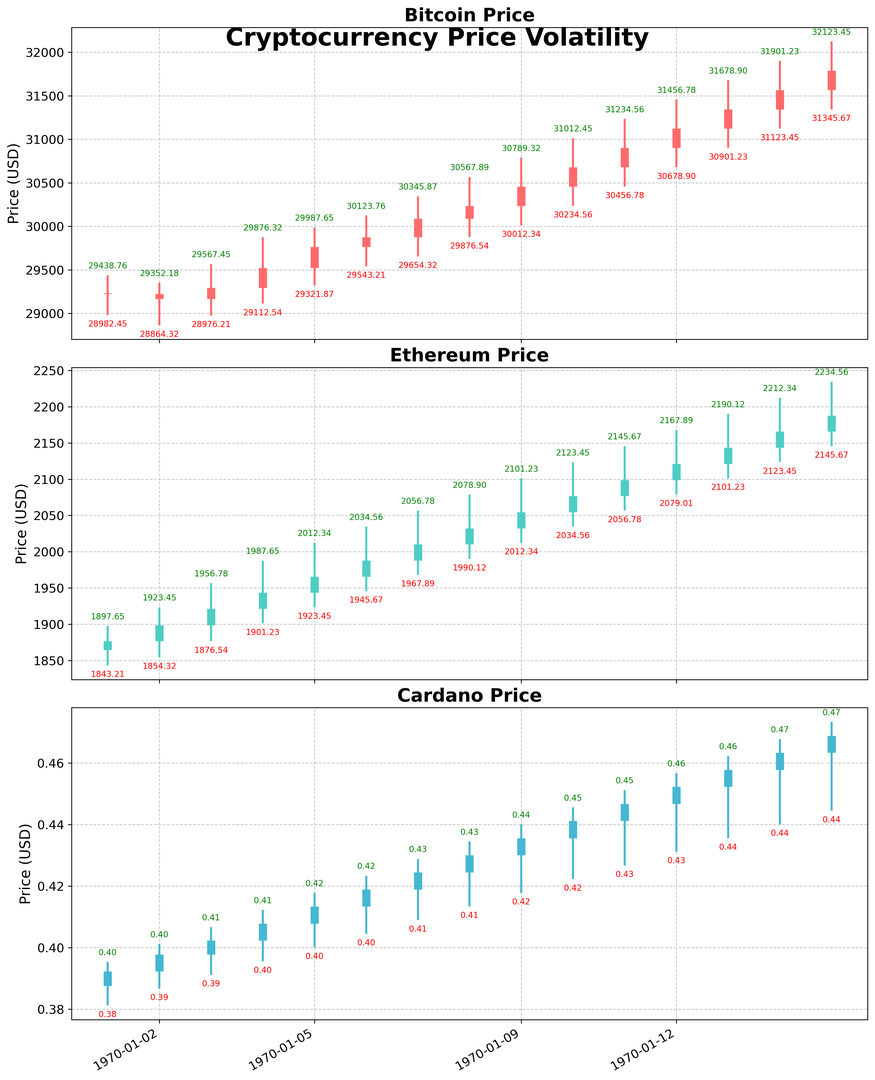What was the highest price reached by Bitcoin and on which date? Check the Bitcoin plot for the highest vertical line specifying the highest price and corresponding date. The highest price is on May 15 at 32,123.45 USD.
Answer: May 15, 32,123.45 USD On which date did Ethereum have the lowest closing price within the month? Look for the shortest vertical line segment at the bottom of the Ethereum plot indicating the lowest closing price. The lowest closing price for Ethereum was on May 1 at 1,876.54 USD.
Answer: May 1, 1,876.54 USD Which cryptocurrency had the smallest price range between the highest and lowest prices on May 15? Compare the candlestick heights of Bitcoin, Ethereum, and Cardano on May 15 to identify the smallest difference between the highest and lowest prices. Cardano had the smallest price range with 0.4734 - 0.4445 = 0.0289 USD.
Answer: Cardano What was the average closing price of Ethereum from May 1 to May 7? Sum the closing prices of Ethereum from May 1 to May 7 and divide by the number of days. (1876.54 + 1898.76 + 1921.23 + 1943.45 + 1965.67 + 1987.89 + 2010.12) / 7 = 1,943.38 USD
Answer: 1,943.38 USD Which currency had the highest price increase from opening to closing on May 5? Compare the difference between opening and closing prices for Bitcoin, Ethereum, and Cardano on May 5. Bitcoin had an increase from 29,523.18 to 29,765.43 = 242.25, Ethereum from 1,943.45 to 1,965.67 = 22.22, and Cardano from 0.4078 to 0.4134 = 0.0056 USD. Bitcoin had the highest increase.
Answer: Bitcoin On May 11, did Bitcoin or Ethereum have a greater high price? Compare the high prices of Bitcoin and Ethereum on May 11. Bitcoin's high was 31,234.56 USD, and Ethereum's high was 2,145.67 USD. Bitcoin had a greater high price.
Answer: Bitcoin How does the price volatility of Cardano on May 9 compare to its price volatility on May 10? Calculate and compare the range (high - low) for Cardano on both May 9 and May 10. On May 9, range = 0.4401 - 0.4178 = 0.0223. On May 10, range = 0.4456 - 0.4223 = 0.0233. The volatility was slightly higher on May 10.
Answer: May 10 was higher Which day had the most significant price drop from open to close for Bitcoin within the month? Look for the day with the largest negative difference between the opening and closing prices on the Bitcoin chart. On May 2, Bitcoin opened at 29,223.57 and closed at 29,167.89, a drop of 55.68 USD.
Answer: May 2 Between May 7 and May 10, which currency showed the highest closing price trend? Compare the closing prices of Bitcoin, Ethereum, and Cardano from May 7 to May 10 to see the trend. Bitcoin's closing increased from 30,087.65 to 30,678.90. Ethereum's closing increased from 2,010.12 to 2,076.78. Cardano's closing increased from 0.4245 to 0.4412. Bitcoin showed the highest trend.
Answer: Bitcoin 